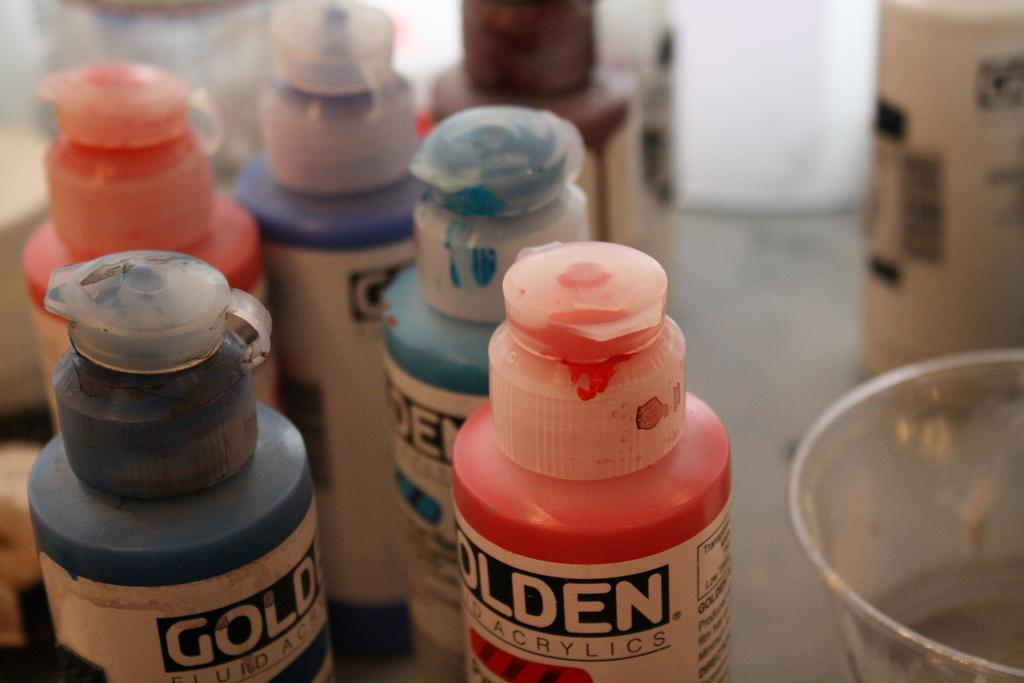What type of containers are visible in the image? There are bottles and a bowl in the image. Can you describe the contents of the bowl? The provided facts do not mention the contents of the bowl. What type of wilderness can be seen in the background of the image? There is no wilderness visible in the image; it only features bottles and a bowl. How many rings are visible on the bottles in the image? The provided facts do not mention the number of rings on the bottles. 